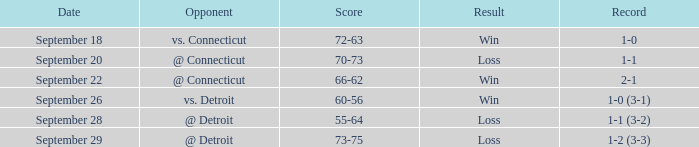WHAT IS THE RESULT WITH A SCORE OF 70-73? Loss. 